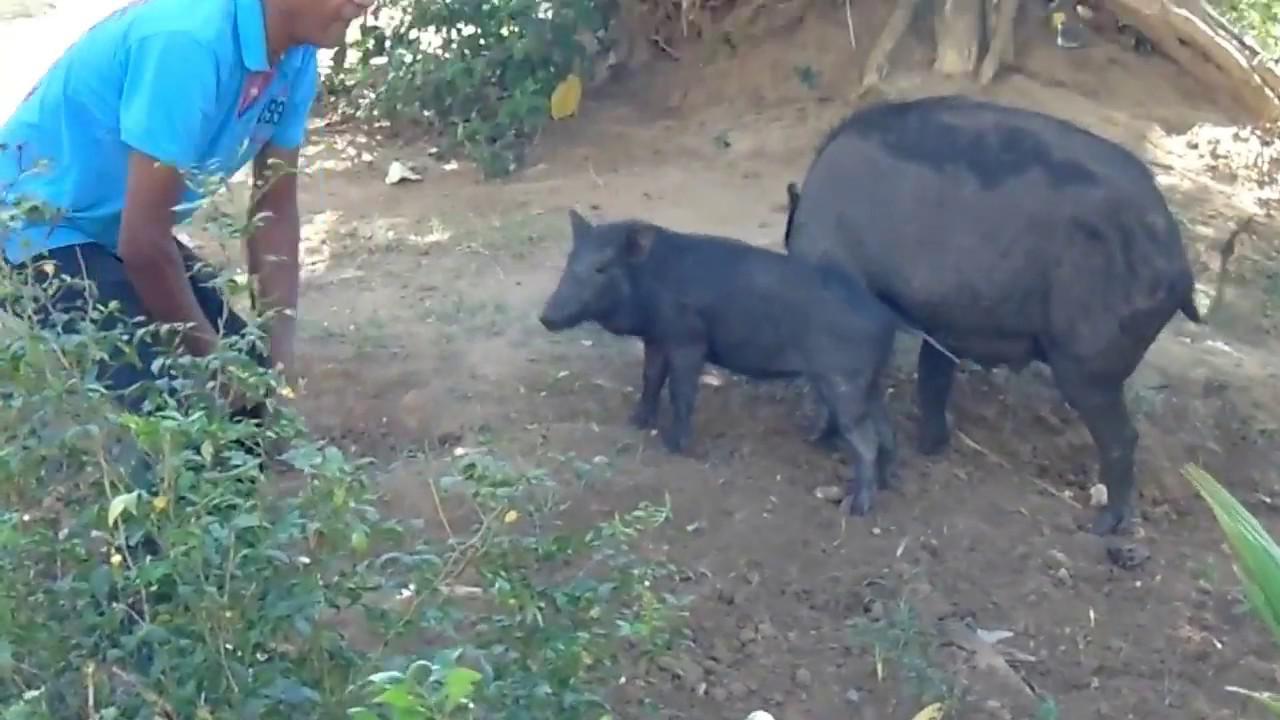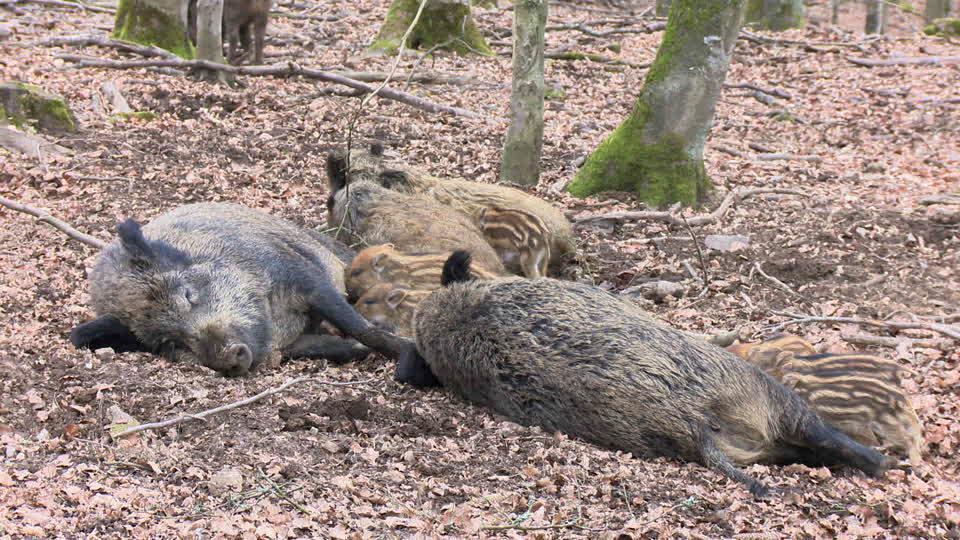The first image is the image on the left, the second image is the image on the right. Evaluate the accuracy of this statement regarding the images: "An image shows at least one wild pig standing by a carcass.". Is it true? Answer yes or no. No. The first image is the image on the left, the second image is the image on the right. For the images shown, is this caption "One images shows a human in close proximity to two boars." true? Answer yes or no. Yes. 